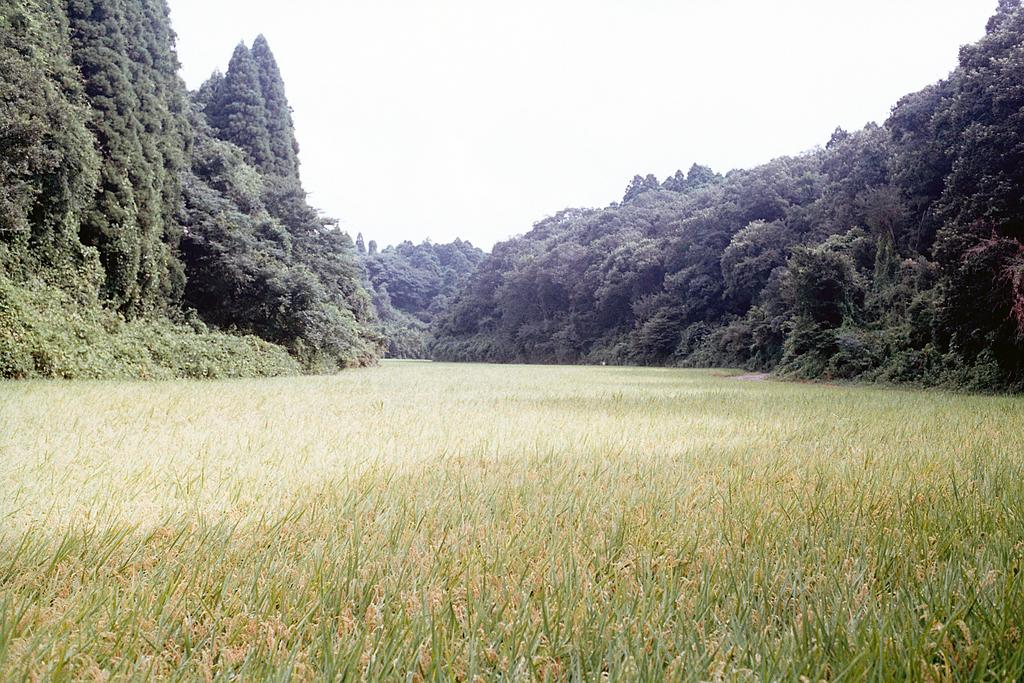What type of ground covering is visible in the image? The ground is covered with grass. What type of vegetation is present in the image? There are many trees in the image. What type of sail can be seen on the trees in the image? There is no sail present in the image; it only features grass and trees. 